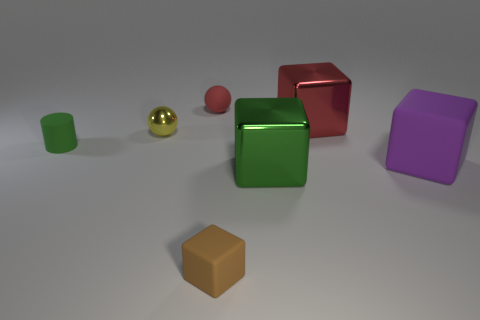There is another tiny object that is the same shape as the small yellow object; what material is it?
Your response must be concise. Rubber. What number of cyan objects are matte spheres or tiny spheres?
Make the answer very short. 0. Is there any other thing of the same color as the tiny rubber sphere?
Your response must be concise. Yes. There is a small cylinder that is left of the big thing that is in front of the big purple cube; what color is it?
Offer a terse response. Green. Are there fewer balls in front of the tiny red sphere than tiny rubber things to the left of the yellow metal ball?
Keep it short and to the point. No. There is a big cube that is the same color as the small cylinder; what is it made of?
Ensure brevity in your answer.  Metal. What number of objects are brown matte blocks on the left side of the large green metal object or tiny purple metallic things?
Make the answer very short. 1. Does the rubber thing that is to the left of the yellow metallic object have the same size as the tiny yellow sphere?
Your answer should be very brief. Yes. Are there fewer tiny matte cylinders behind the yellow metallic object than big metal cubes?
Ensure brevity in your answer.  Yes. What is the material of the green block that is the same size as the purple rubber block?
Your answer should be very brief. Metal. 